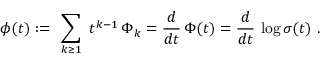Convert formula to latex. <formula><loc_0><loc_0><loc_500><loc_500>\phi ( t ) \colon = \ \sum _ { k \geq 1 } \ t ^ { k - 1 } \, \Phi _ { k } = { \frac { d } { d t } } \, \Phi ( t ) = { \frac { d } { d t } } \, \log \sigma ( t ) \ .</formula> 